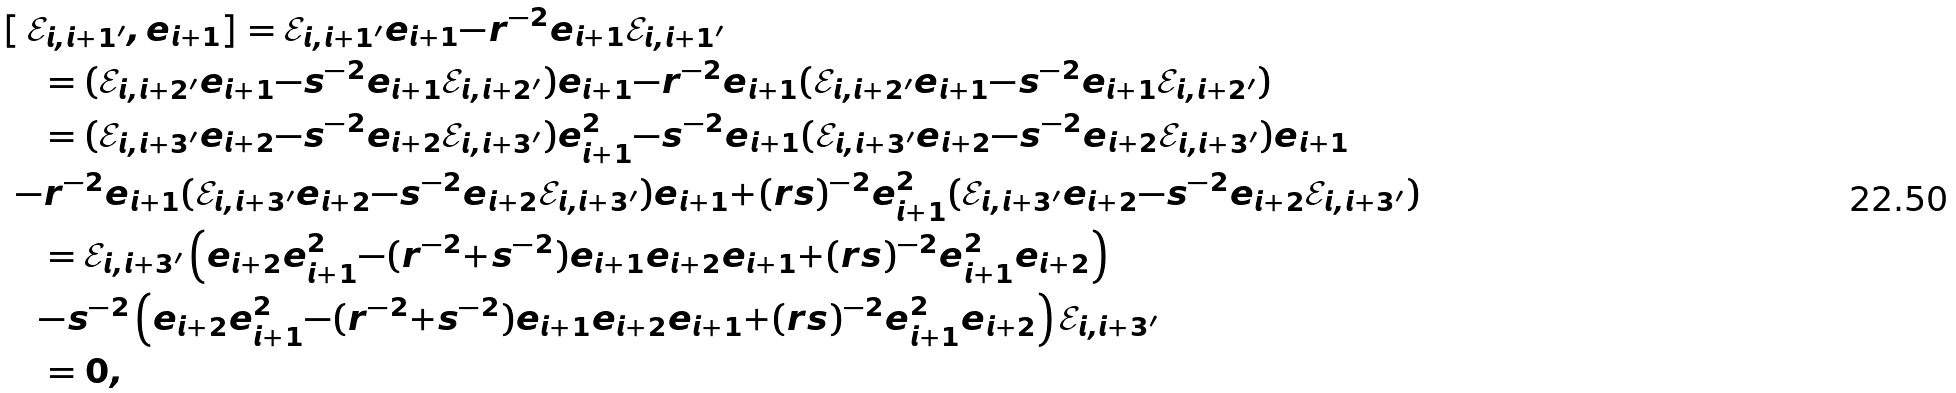Convert formula to latex. <formula><loc_0><loc_0><loc_500><loc_500>& [ \, \mathcal { E } _ { i , i + 1 ^ { \prime } } , e _ { i + 1 } ] = \mathcal { E } _ { i , i + 1 ^ { \prime } } e _ { i + 1 } { - } r ^ { - 2 } e _ { i + 1 } \mathcal { E } _ { i , i + 1 ^ { \prime } } \\ & \quad = ( \mathcal { E } _ { i , i + 2 ^ { \prime } } e _ { i + 1 } { - } s ^ { - 2 } e _ { i + 1 } \mathcal { E } _ { i , i + 2 ^ { \prime } } ) e _ { i + 1 } { - } r ^ { - 2 } e _ { i + 1 } ( \mathcal { E } _ { i , i + 2 ^ { \prime } } e _ { i + 1 } { - } s ^ { - 2 } e _ { i + 1 } \mathcal { E } _ { i , i + 2 ^ { \prime } } ) \\ & \quad = ( \mathcal { E } _ { i , i + 3 ^ { \prime } } e _ { i + 2 } { - } s ^ { - 2 } e _ { i + 2 } \mathcal { E } _ { i , i + 3 ^ { \prime } } ) e _ { i + 1 } ^ { 2 } { - } s ^ { - 2 } e _ { i + 1 } ( \mathcal { E } _ { i , i + 3 ^ { \prime } } e _ { i + 2 } { - } s ^ { - 2 } e _ { i + 2 } \mathcal { E } _ { i , i + 3 ^ { \prime } } ) e _ { i + 1 } \\ & \ { - } r ^ { - 2 } e _ { i + 1 } ( \mathcal { E } _ { i , i + 3 ^ { \prime } } e _ { i + 2 } { - } s ^ { - 2 } e _ { i + 2 } \mathcal { E } _ { i , i + 3 ^ { \prime } } ) e _ { i + 1 } { + } ( r s ) ^ { - 2 } e _ { i + 1 } ^ { 2 } ( \mathcal { E } _ { i , i + 3 ^ { \prime } } e _ { i + 2 } { - } s ^ { - 2 } e _ { i + 2 } \mathcal { E } _ { i , i + 3 ^ { \prime } } ) \\ & \quad = \mathcal { E } _ { i , i + 3 ^ { \prime } } \left ( e _ { i + 2 } e _ { i + 1 } ^ { 2 } { - } ( r ^ { - 2 } { + } s ^ { - 2 } ) e _ { i + 1 } e _ { i + 2 } e _ { i + 1 } { + } ( r s ) ^ { - 2 } e _ { i + 1 } ^ { 2 } e _ { i + 2 } \right ) \\ & \quad { - } s ^ { - 2 } \left ( e _ { i + 2 } e _ { i + 1 } ^ { 2 } { - } ( r ^ { - 2 } { + } s ^ { - 2 } ) e _ { i + 1 } e _ { i + 2 } e _ { i + 1 } { + } ( r s ) ^ { - 2 } e _ { i + 1 } ^ { 2 } e _ { i + 2 } \right ) \mathcal { E } _ { i , i + 3 ^ { \prime } } \\ & \quad = 0 ,</formula> 